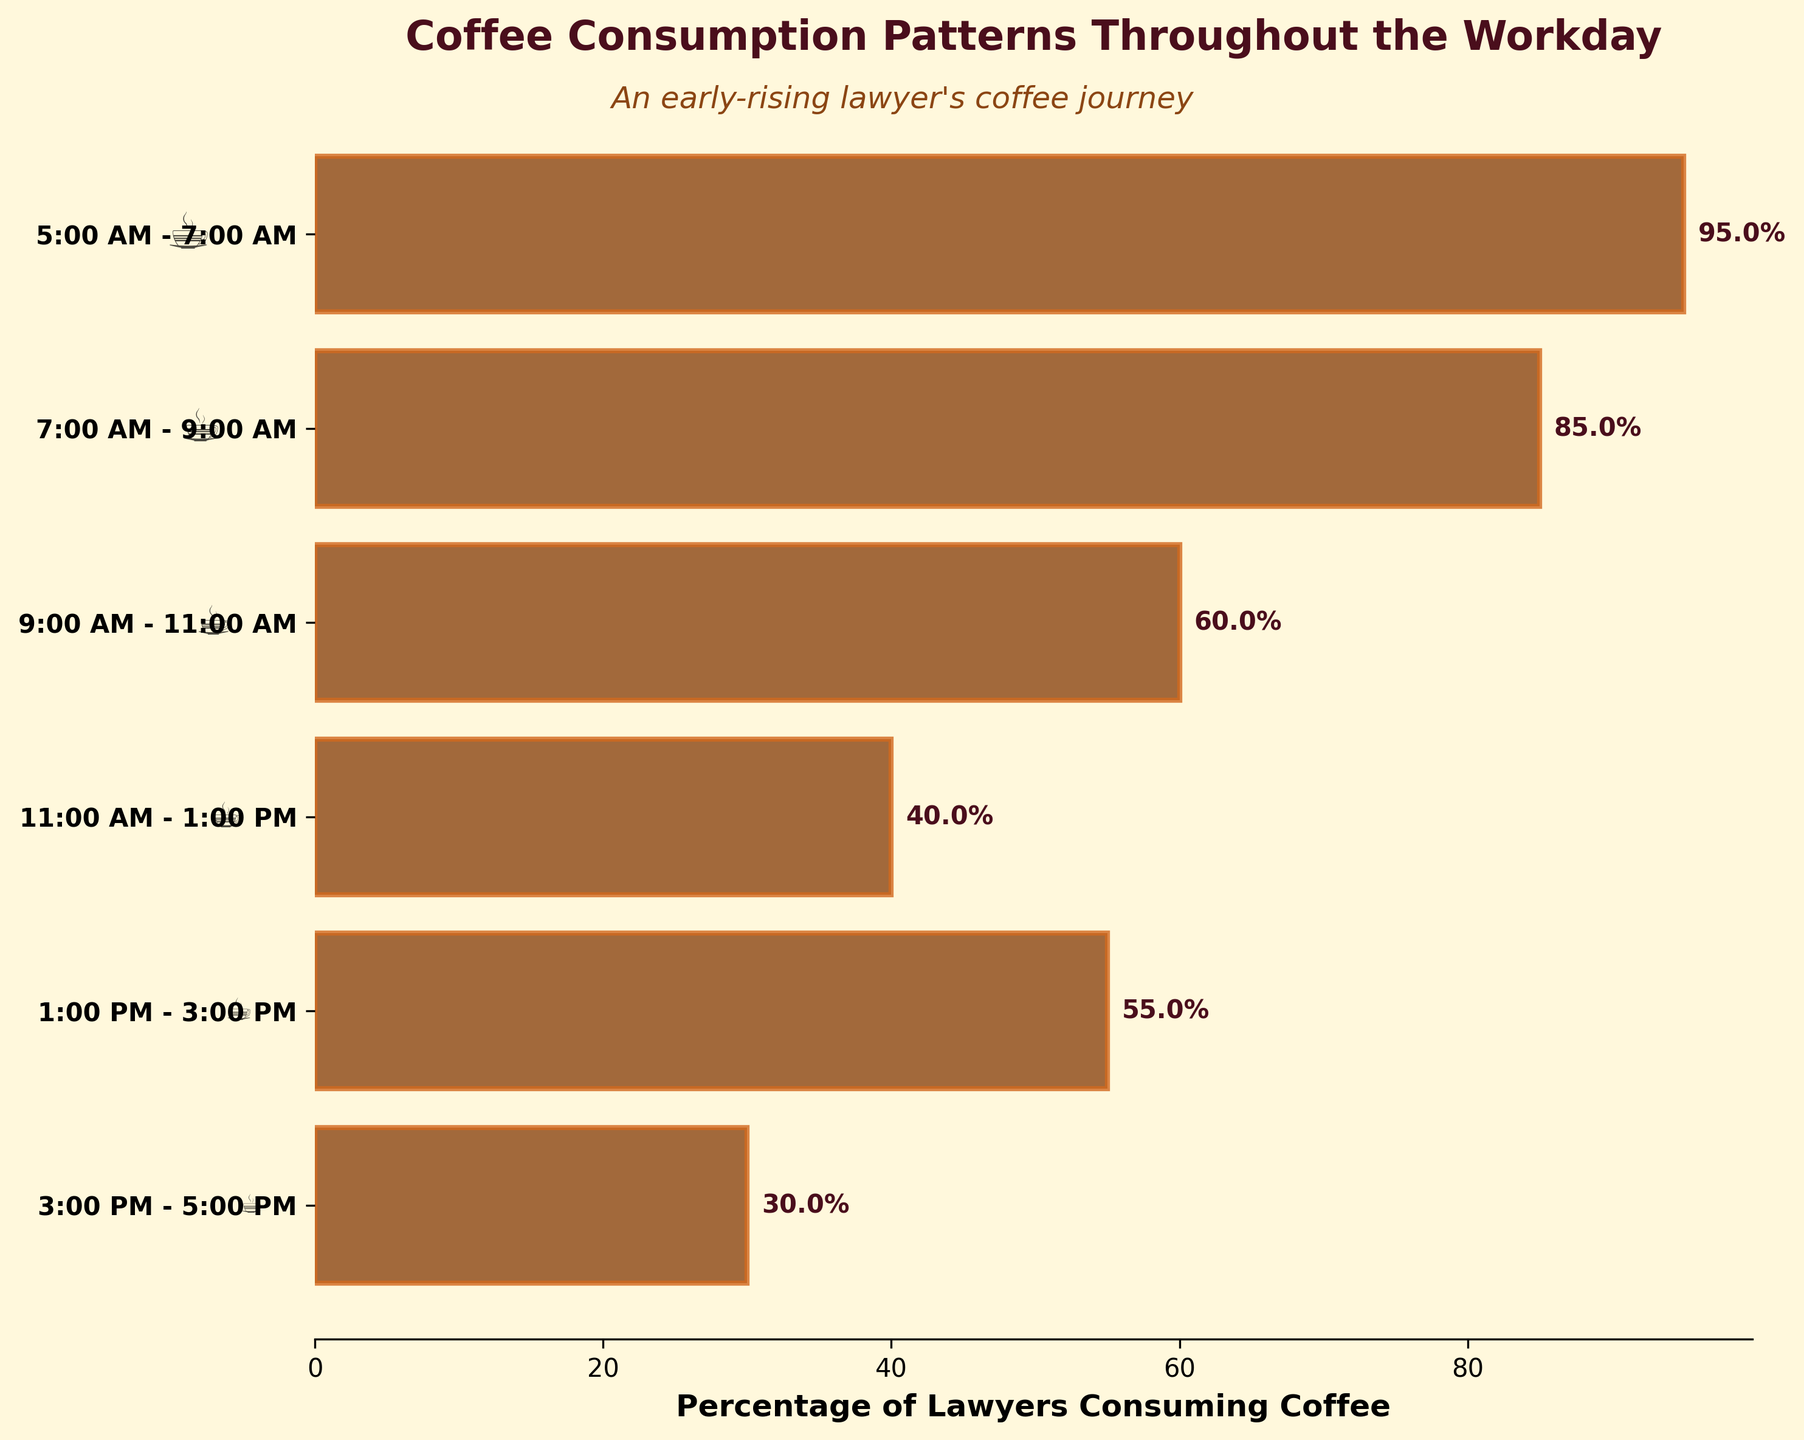Which time of day has the highest percentage of lawyers consuming coffee? The time of day labeled "5:00 AM - 7:00 AM" has the highest percentage of lawyers consuming coffee, as indicated by the height of the bar in the funnel chart.
Answer: 5:00 AM - 7:00 AM What is the percentage of lawyers consuming coffee between 3:00 PM and 5:00 PM? The figure shows that the percentage of lawyers consuming coffee between "3:00 PM - 5:00 PM" is represented by the corresponding bar with the label "3:00 PM - 5:00 PM," which is 30%.
Answer: 30% How does coffee consumption from 7:00 AM - 9:00 AM compare to that from 9:00 AM - 11:00 AM? The bar representing "7:00 AM - 9:00 AM" is higher than the bar for "9:00 AM - 11:00 AM," indicating a higher percentage of lawyers consuming coffee during the earlier time. Specifically, 85% compared to 60%.
Answer: 85% is greater than 60% Calculate the average percentage of coffee consumption across all the specified times of the workday. To find the average, sum the percentages (95 + 85 + 60 + 40 + 55 + 30 = 365) and divide by the number of time intervals (6). So, the average is 365 / 6.
Answer: 60.83% Is the percentage of coffee consumption higher or lower in the afternoon (1:00 PM - 3:00 PM) compared to mid-morning (9:00 AM - 11:00 AM)? The bar for "1:00 PM - 3:00 PM" shows 55%, which is lower than the 60% shown for "9:00 AM - 11:00 AM," indicating lower consumption in the afternoon.
Answer: Lower What is the difference in coffee consumption between the highest and lowest times of the day? The highest coffee consumption is 95% (5:00 AM - 7:00 AM) and the lowest is 30% (3:00 PM - 5:00 PM). The difference between these is 95% - 30%.
Answer: 65% Which period shows a decrease in coffee consumption after an increase in the earlier period? After an increase in the morning period "1:00 PM - 3:00 PM" from the previous "11:00 AM - 1:00 PM," there is a subsequent decrease in "3:00 PM - 5:00 PM."
Answer: 3:00 PM - 5:00 PM Why might the subtitle "An early-rising lawyer's coffee journey" be relevant to this chart? The data shows the highest coffee consumption percentage is early in the morning (5:00 AM - 7:00 AM) for lawyers, supporting the idea that early-rising lawyers heavily rely on coffee to start their day.
Answer: High consumption early What is the trend in coffee consumption from the start to the end of the workday? The trend shows a general decrease in coffee consumption as the day progresses from early morning (95%) to late afternoon (30%), with a slight resurgence during "1:00 PM - 3:00 PM."
Answer: Decreasing with a slight bump 